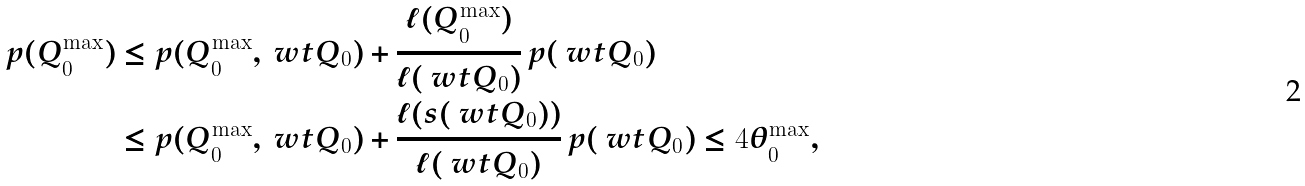Convert formula to latex. <formula><loc_0><loc_0><loc_500><loc_500>p ( Q _ { 0 } ^ { \max } ) & \leq p ( Q _ { 0 } ^ { \max } , \ w t Q _ { 0 } ) + \frac { \ell ( Q _ { 0 } ^ { \max } ) } { \ell ( \ w t Q _ { 0 } ) } \, p ( \ w t Q _ { 0 } ) \\ & \leq p ( Q _ { 0 } ^ { \max } , \ w t Q _ { 0 } ) + \frac { \ell ( s ( \ w t Q _ { 0 } ) ) } { \ell ( \ w t Q _ { 0 } ) } \, p ( \ w t Q _ { 0 } ) \leq 4 \theta _ { 0 } ^ { \max } ,</formula> 